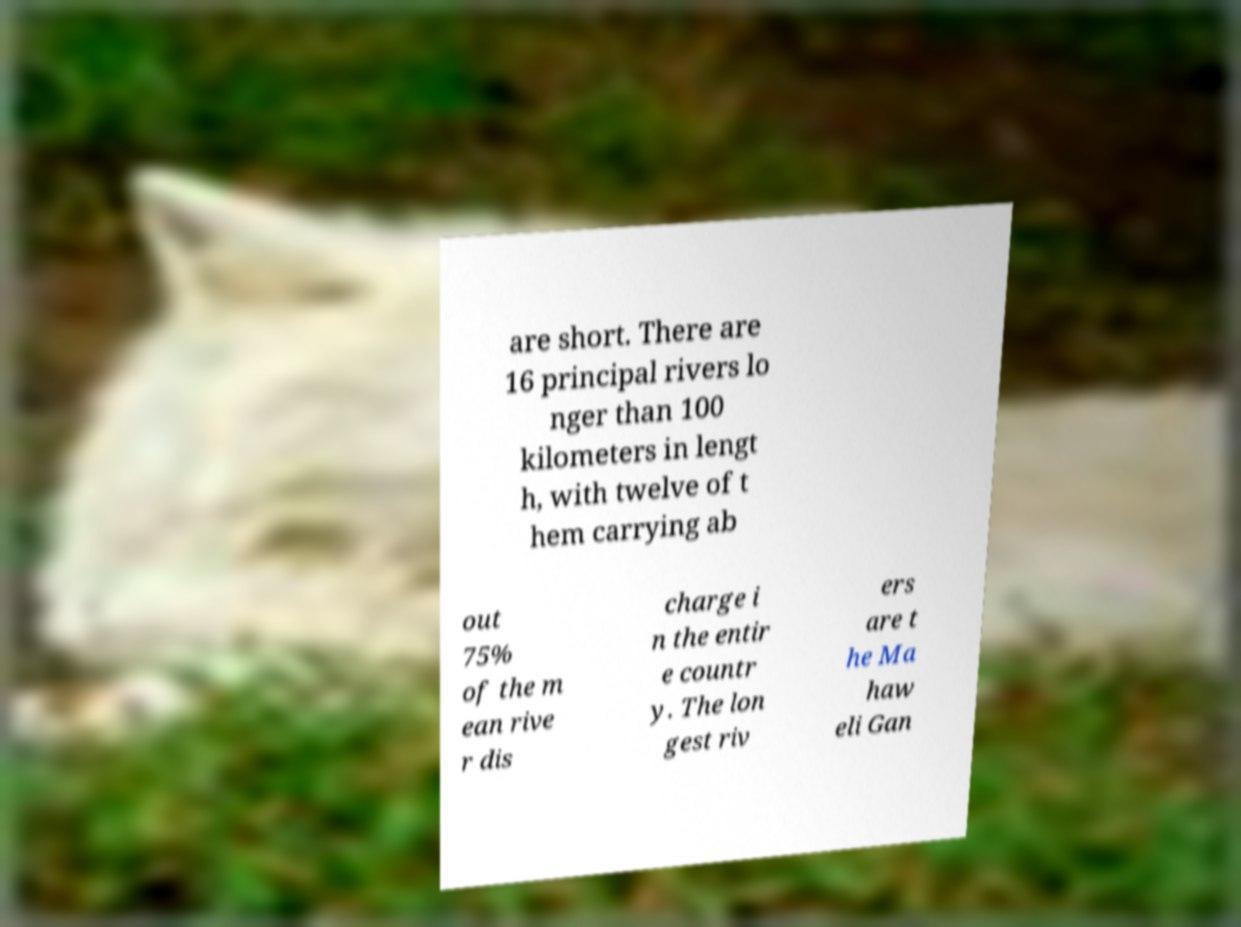For documentation purposes, I need the text within this image transcribed. Could you provide that? are short. There are 16 principal rivers lo nger than 100 kilometers in lengt h, with twelve of t hem carrying ab out 75% of the m ean rive r dis charge i n the entir e countr y. The lon gest riv ers are t he Ma haw eli Gan 